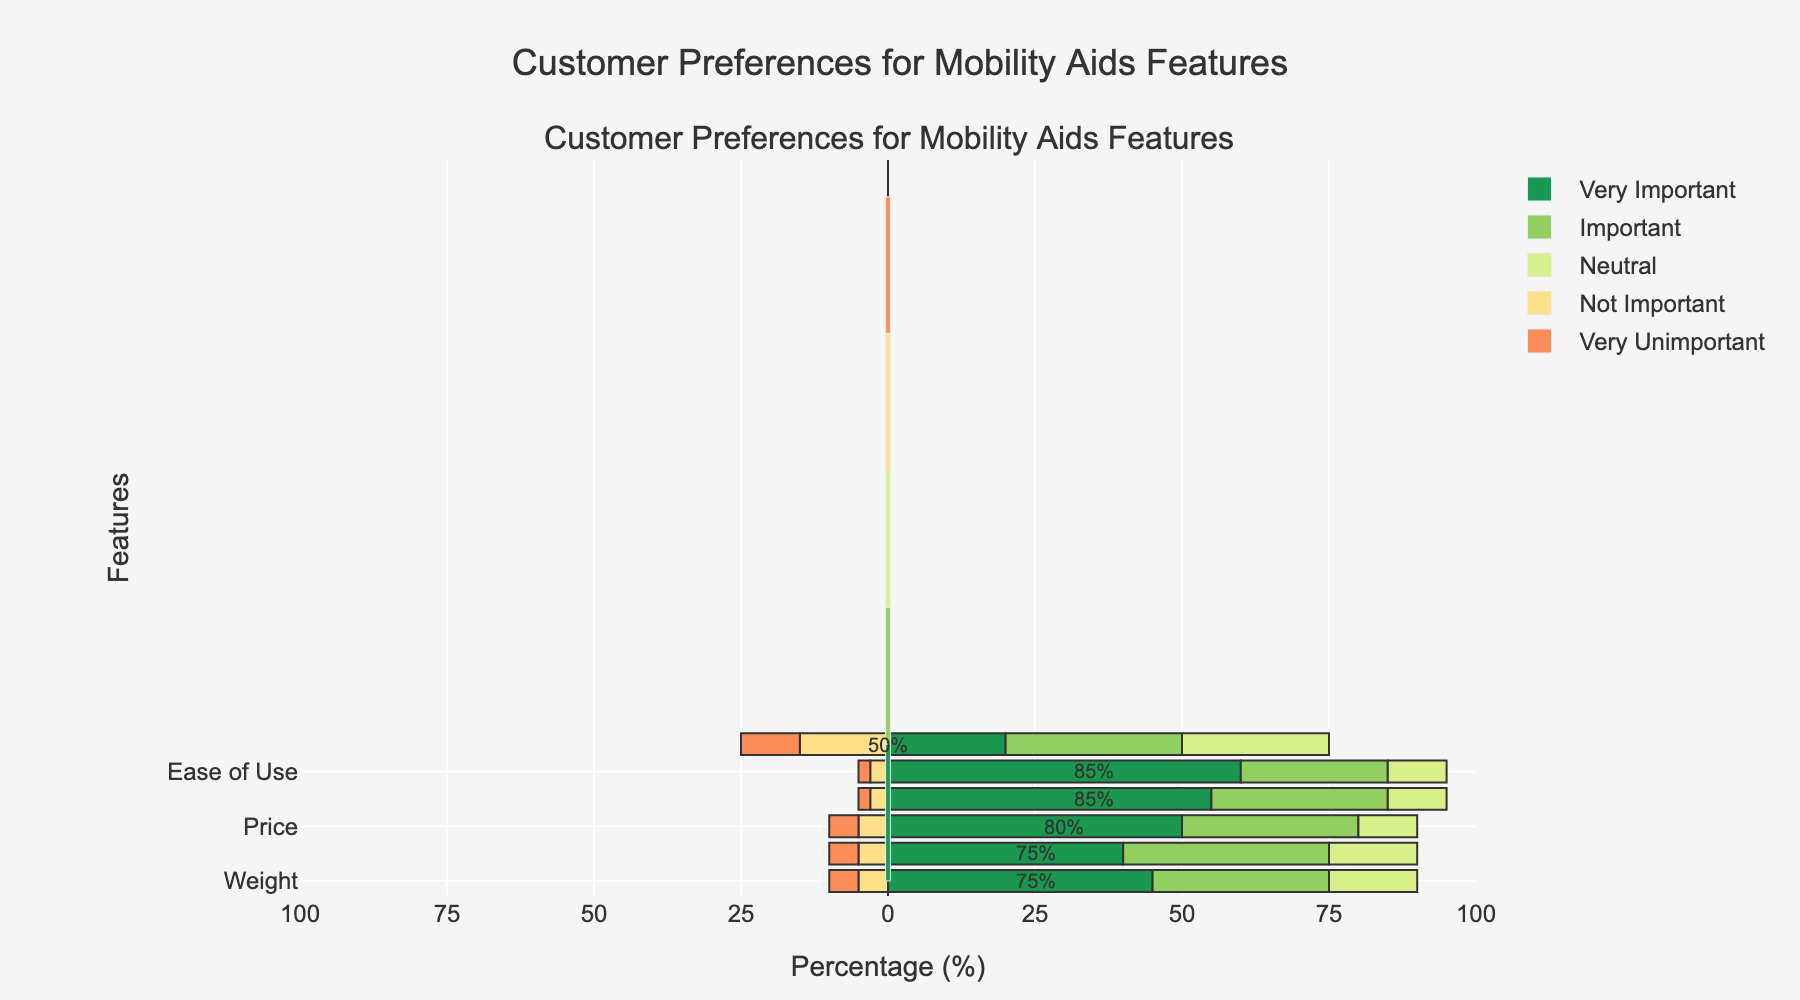What percentage of customers rated 'Durability' as 'Very Important'? Look at the bar corresponding to 'Durability' and check the percentage value associated with 'Very Important'. This is the length of the green segment in the bar.
Answer: 55% Which feature has the highest percentage of customers rating it as 'Very Important'? Compare the green segments of each bar. The bar with the longest green segment represents the feature rated as 'Very Important' by the highest percentage of customers.
Answer: Ease of Use What is the combined percentage of customers who rated 'Aesthetics' as either 'Not Important' or 'Very Unimportant'? Look at the bar for 'Aesthetics', adding the lengths of the segments representing 'Not Important' (orange) and 'Very Unimportant' (red). The respective percentages are 15% and 10%. Summing them gives 15% + 10% = 25%
Answer: 25% How does the importance of 'Foldability' compare to 'Price' for the 'Important' category? Compare the lengths of the light green segments for 'Foldability' and 'Price'. 'Foldability' has a value of 35% and 'Price' has a value of 30%.
Answer: Foldability is 5% higher Which features have more than 80% of customers rating them as either 'Very Important' or 'Important'? Add the percentages for 'Very Important' and 'Important' for each feature. Identify which of these sums are greater than 80%.
Answer: Weight, Price, Durability, Ease of Use How does the overall rating accessibility (combine 'Very Important', 'Important', and 'Neutral') of 'Weight' compare to 'Aesthetics'? Add the percentages for 'Very Important', 'Important', and 'Neutral' for both 'Weight' and 'Aesthetics'. 'Weight' is 45% + 30% + 15% = 90%, and 'Aesthetics' is 20% + 30% + 25% = 75%. Then compare the two values.
Answer: Weight is 15% higher Which feature has the lowest percentage rated as 'Neutral'? Compare the yellow segments (representing 'Neutral') of each bar. The feature with the shortest yellow segment has the lowest percentage for the 'Neutral' rating.
Answer: Price and Durability Rank the features based on the percentage of 'Very Unimportant' ratings from highest to lowest Compare the red segments of each bar to rank the features. Aesthetics has the longest red segment followed by Weight, Foldability, and Price, which share the same length, last are Durability and Ease of Use.
Answer: Aesthetics, Weight/Foldability/Price, Durability/Ease of Use What is the total percentage of customers who rated 'Ease of Use' as below 'Neutral' (i.e., 'Not Important' or 'Very Unimportant')? Add the portions of 'Ease of Use' corresponding to 'Not Important' (3%) and 'Very Unimportant' (2%). This results in 3% + 2% = 5%.
Answer: 5% How many features have at least 80% of customers rating them between 'Very Important' and 'Neutral'? For each feature, add the percentages of 'Very Important', 'Important', and 'Neutral'. Features with a sum of at least 80% meet the criteria.
Answer: All features 